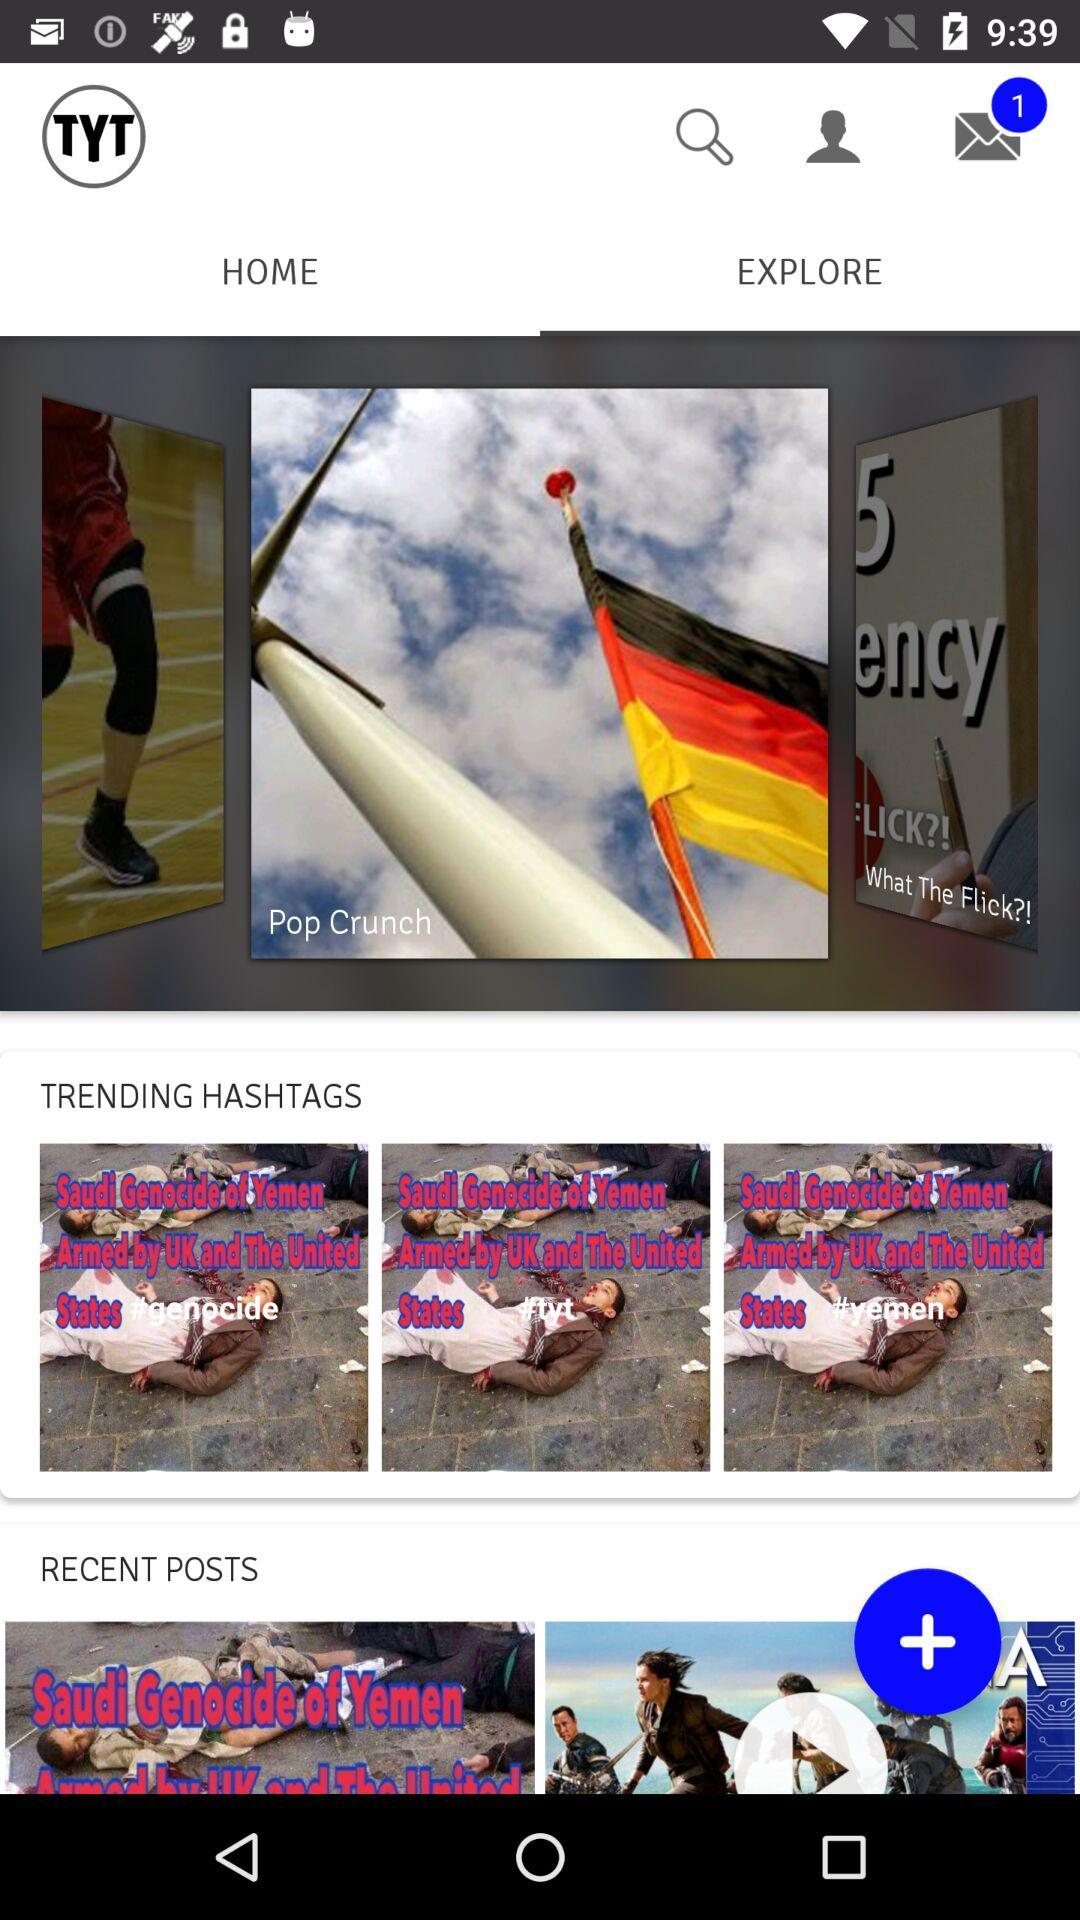Which tab is selected? The selected tab is "EXPLORE". 